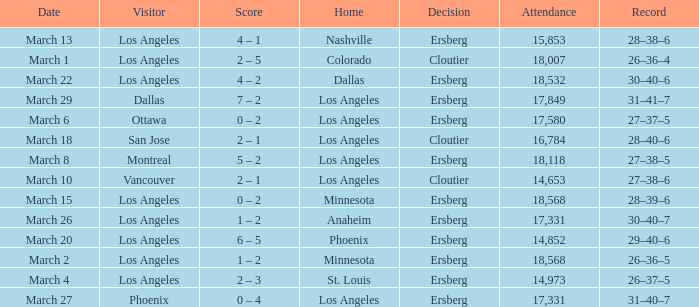What is the Decision listed when the Home was Colorado? Cloutier. 